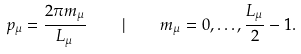<formula> <loc_0><loc_0><loc_500><loc_500>p _ { \mu } = \frac { 2 \pi m _ { \mu } } { L _ { \mu } } \quad | \quad m _ { \mu } = 0 , \dots , \frac { L _ { \mu } } { 2 } - 1 .</formula> 